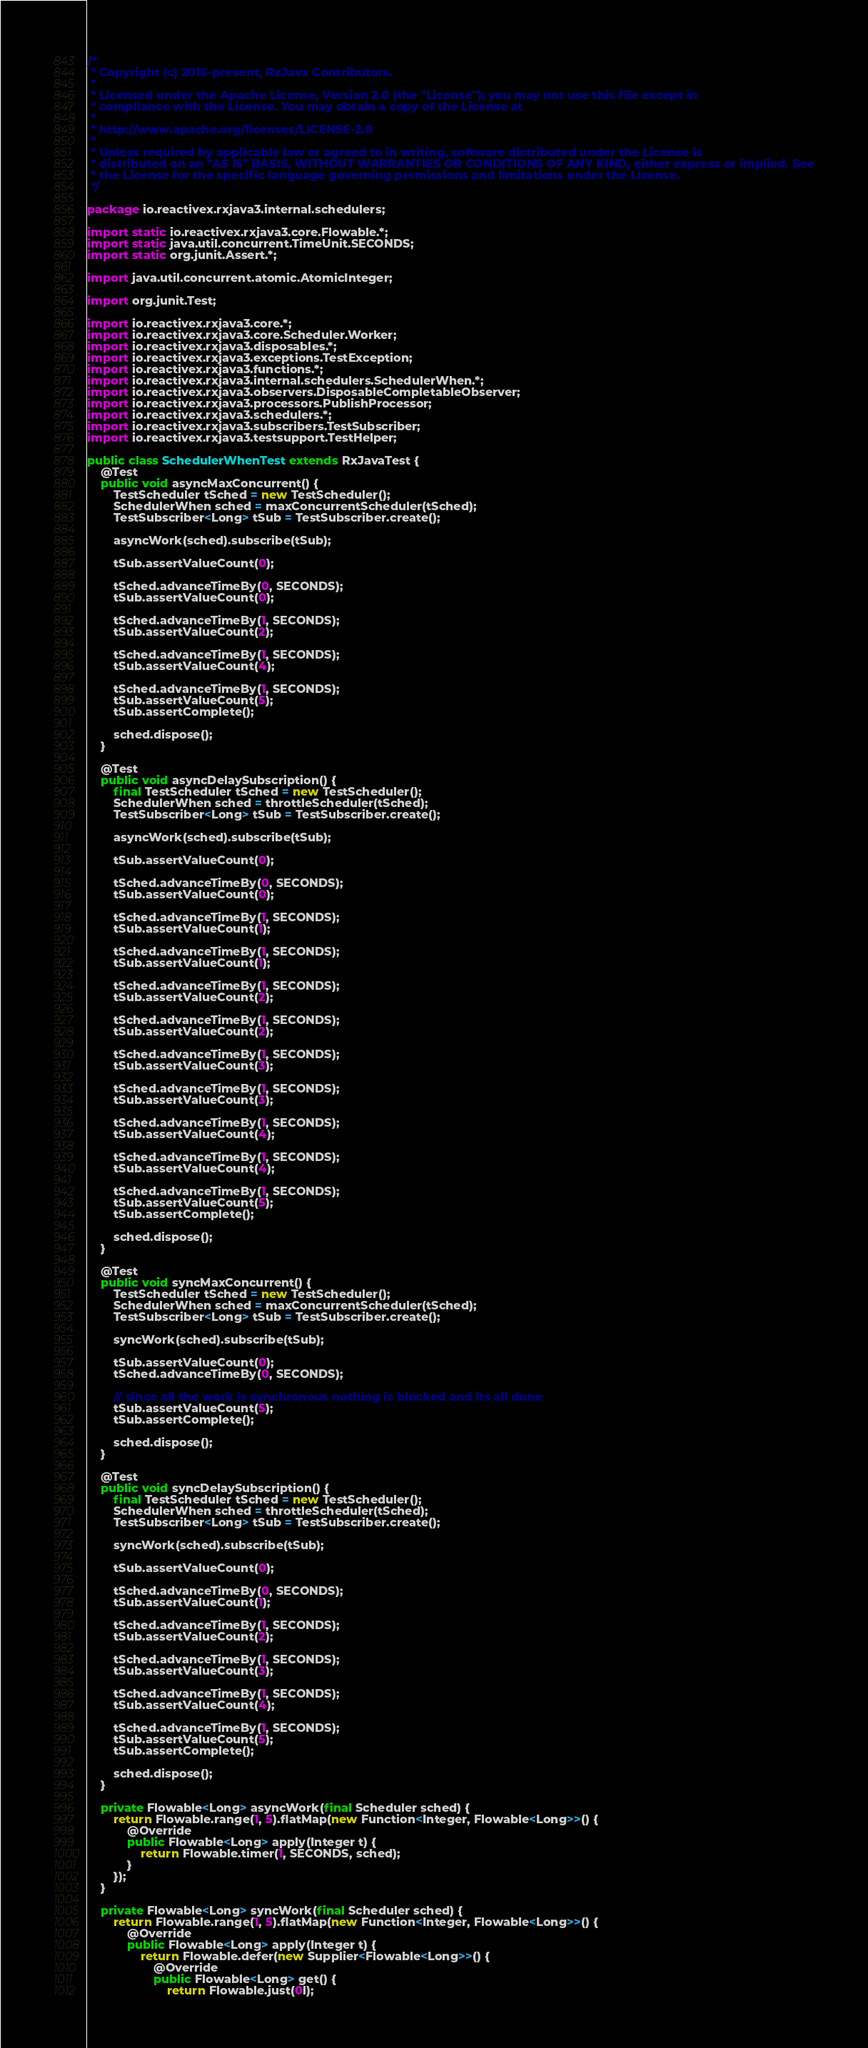<code> <loc_0><loc_0><loc_500><loc_500><_Java_>/*
 * Copyright (c) 2016-present, RxJava Contributors.
 *
 * Licensed under the Apache License, Version 2.0 (the "License"); you may not use this file except in
 * compliance with the License. You may obtain a copy of the License at
 *
 * http://www.apache.org/licenses/LICENSE-2.0
 *
 * Unless required by applicable law or agreed to in writing, software distributed under the License is
 * distributed on an "AS IS" BASIS, WITHOUT WARRANTIES OR CONDITIONS OF ANY KIND, either express or implied. See
 * the License for the specific language governing permissions and limitations under the License.
 */

package io.reactivex.rxjava3.internal.schedulers;

import static io.reactivex.rxjava3.core.Flowable.*;
import static java.util.concurrent.TimeUnit.SECONDS;
import static org.junit.Assert.*;

import java.util.concurrent.atomic.AtomicInteger;

import org.junit.Test;

import io.reactivex.rxjava3.core.*;
import io.reactivex.rxjava3.core.Scheduler.Worker;
import io.reactivex.rxjava3.disposables.*;
import io.reactivex.rxjava3.exceptions.TestException;
import io.reactivex.rxjava3.functions.*;
import io.reactivex.rxjava3.internal.schedulers.SchedulerWhen.*;
import io.reactivex.rxjava3.observers.DisposableCompletableObserver;
import io.reactivex.rxjava3.processors.PublishProcessor;
import io.reactivex.rxjava3.schedulers.*;
import io.reactivex.rxjava3.subscribers.TestSubscriber;
import io.reactivex.rxjava3.testsupport.TestHelper;

public class SchedulerWhenTest extends RxJavaTest {
    @Test
    public void asyncMaxConcurrent() {
        TestScheduler tSched = new TestScheduler();
        SchedulerWhen sched = maxConcurrentScheduler(tSched);
        TestSubscriber<Long> tSub = TestSubscriber.create();

        asyncWork(sched).subscribe(tSub);

        tSub.assertValueCount(0);

        tSched.advanceTimeBy(0, SECONDS);
        tSub.assertValueCount(0);

        tSched.advanceTimeBy(1, SECONDS);
        tSub.assertValueCount(2);

        tSched.advanceTimeBy(1, SECONDS);
        tSub.assertValueCount(4);

        tSched.advanceTimeBy(1, SECONDS);
        tSub.assertValueCount(5);
        tSub.assertComplete();

        sched.dispose();
    }

    @Test
    public void asyncDelaySubscription() {
        final TestScheduler tSched = new TestScheduler();
        SchedulerWhen sched = throttleScheduler(tSched);
        TestSubscriber<Long> tSub = TestSubscriber.create();

        asyncWork(sched).subscribe(tSub);

        tSub.assertValueCount(0);

        tSched.advanceTimeBy(0, SECONDS);
        tSub.assertValueCount(0);

        tSched.advanceTimeBy(1, SECONDS);
        tSub.assertValueCount(1);

        tSched.advanceTimeBy(1, SECONDS);
        tSub.assertValueCount(1);

        tSched.advanceTimeBy(1, SECONDS);
        tSub.assertValueCount(2);

        tSched.advanceTimeBy(1, SECONDS);
        tSub.assertValueCount(2);

        tSched.advanceTimeBy(1, SECONDS);
        tSub.assertValueCount(3);

        tSched.advanceTimeBy(1, SECONDS);
        tSub.assertValueCount(3);

        tSched.advanceTimeBy(1, SECONDS);
        tSub.assertValueCount(4);

        tSched.advanceTimeBy(1, SECONDS);
        tSub.assertValueCount(4);

        tSched.advanceTimeBy(1, SECONDS);
        tSub.assertValueCount(5);
        tSub.assertComplete();

        sched.dispose();
    }

    @Test
    public void syncMaxConcurrent() {
        TestScheduler tSched = new TestScheduler();
        SchedulerWhen sched = maxConcurrentScheduler(tSched);
        TestSubscriber<Long> tSub = TestSubscriber.create();

        syncWork(sched).subscribe(tSub);

        tSub.assertValueCount(0);
        tSched.advanceTimeBy(0, SECONDS);

        // since all the work is synchronous nothing is blocked and its all done
        tSub.assertValueCount(5);
        tSub.assertComplete();

        sched.dispose();
    }

    @Test
    public void syncDelaySubscription() {
        final TestScheduler tSched = new TestScheduler();
        SchedulerWhen sched = throttleScheduler(tSched);
        TestSubscriber<Long> tSub = TestSubscriber.create();

        syncWork(sched).subscribe(tSub);

        tSub.assertValueCount(0);

        tSched.advanceTimeBy(0, SECONDS);
        tSub.assertValueCount(1);

        tSched.advanceTimeBy(1, SECONDS);
        tSub.assertValueCount(2);

        tSched.advanceTimeBy(1, SECONDS);
        tSub.assertValueCount(3);

        tSched.advanceTimeBy(1, SECONDS);
        tSub.assertValueCount(4);

        tSched.advanceTimeBy(1, SECONDS);
        tSub.assertValueCount(5);
        tSub.assertComplete();

        sched.dispose();
    }

    private Flowable<Long> asyncWork(final Scheduler sched) {
        return Flowable.range(1, 5).flatMap(new Function<Integer, Flowable<Long>>() {
            @Override
            public Flowable<Long> apply(Integer t) {
                return Flowable.timer(1, SECONDS, sched);
            }
        });
    }

    private Flowable<Long> syncWork(final Scheduler sched) {
        return Flowable.range(1, 5).flatMap(new Function<Integer, Flowable<Long>>() {
            @Override
            public Flowable<Long> apply(Integer t) {
                return Flowable.defer(new Supplier<Flowable<Long>>() {
                    @Override
                    public Flowable<Long> get() {
                        return Flowable.just(0l);</code> 